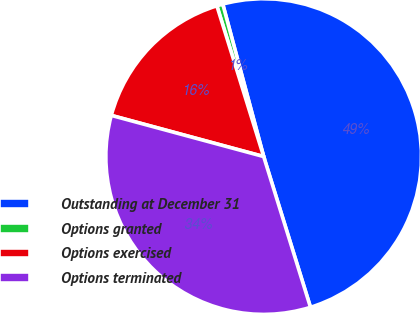Convert chart. <chart><loc_0><loc_0><loc_500><loc_500><pie_chart><fcel>Outstanding at December 31<fcel>Options granted<fcel>Options exercised<fcel>Options terminated<nl><fcel>49.38%<fcel>0.62%<fcel>16.01%<fcel>33.99%<nl></chart> 